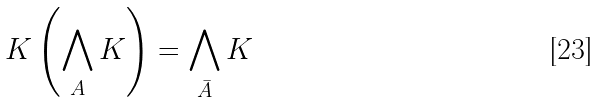<formula> <loc_0><loc_0><loc_500><loc_500>K \left ( \bigwedge _ { A } K \right ) = \bigwedge _ { \bar { A } } K</formula> 